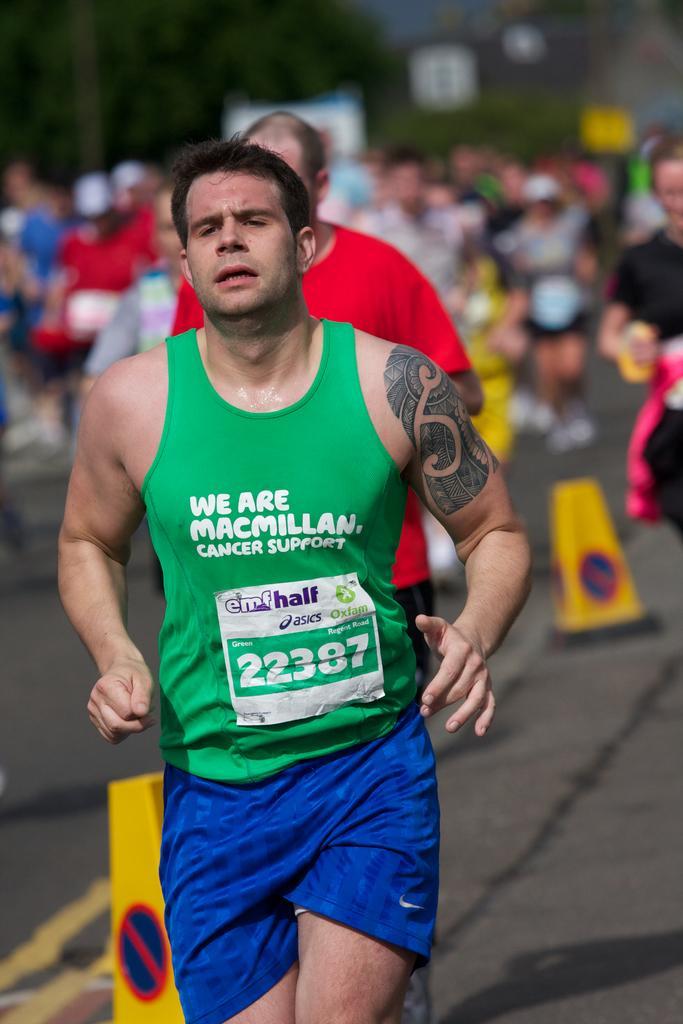Please provide a concise description of this image. In this picture we can see group of people and few are running on the road, beside them we can see road divider blocks and we can see blurry background. 